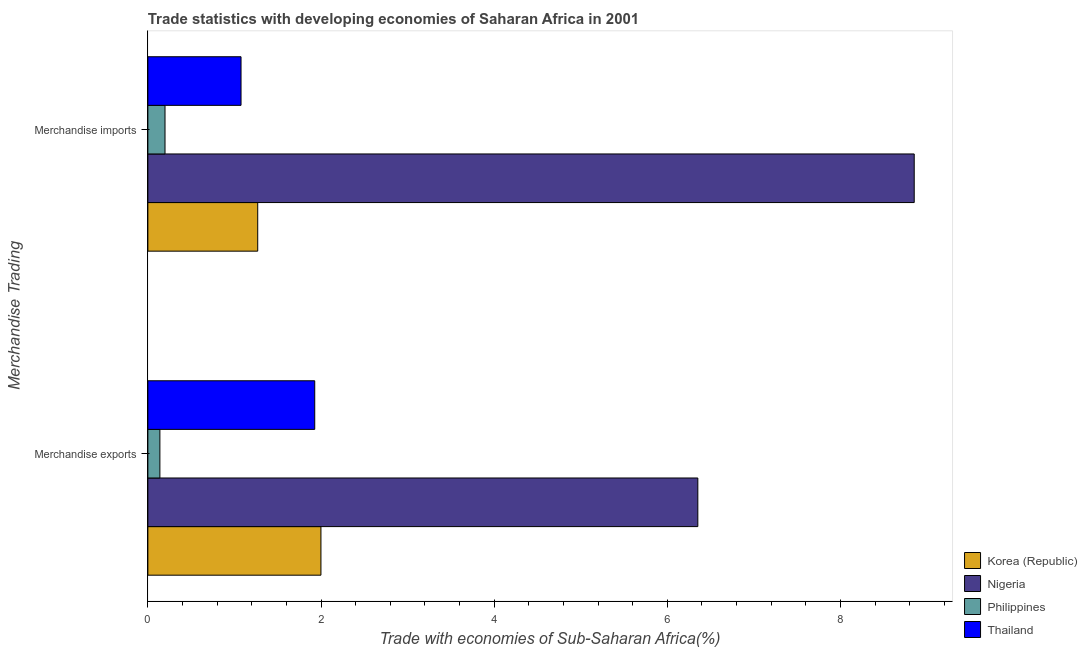Are the number of bars on each tick of the Y-axis equal?
Provide a short and direct response. Yes. What is the merchandise exports in Thailand?
Ensure brevity in your answer.  1.93. Across all countries, what is the maximum merchandise imports?
Keep it short and to the point. 8.85. Across all countries, what is the minimum merchandise imports?
Your answer should be very brief. 0.2. In which country was the merchandise imports maximum?
Ensure brevity in your answer.  Nigeria. In which country was the merchandise exports minimum?
Ensure brevity in your answer.  Philippines. What is the total merchandise imports in the graph?
Provide a succinct answer. 11.39. What is the difference between the merchandise exports in Philippines and that in Korea (Republic)?
Ensure brevity in your answer.  -1.86. What is the difference between the merchandise imports in Philippines and the merchandise exports in Thailand?
Offer a very short reply. -1.73. What is the average merchandise imports per country?
Provide a succinct answer. 2.85. What is the difference between the merchandise imports and merchandise exports in Philippines?
Provide a succinct answer. 0.06. What is the ratio of the merchandise exports in Nigeria to that in Korea (Republic)?
Your answer should be very brief. 3.18. What does the 3rd bar from the top in Merchandise exports represents?
Your answer should be compact. Nigeria. What does the 3rd bar from the bottom in Merchandise exports represents?
Offer a very short reply. Philippines. What is the difference between two consecutive major ticks on the X-axis?
Give a very brief answer. 2. Are the values on the major ticks of X-axis written in scientific E-notation?
Your answer should be compact. No. Does the graph contain any zero values?
Your answer should be very brief. No. Where does the legend appear in the graph?
Offer a terse response. Bottom right. What is the title of the graph?
Give a very brief answer. Trade statistics with developing economies of Saharan Africa in 2001. Does "Panama" appear as one of the legend labels in the graph?
Your answer should be compact. No. What is the label or title of the X-axis?
Give a very brief answer. Trade with economies of Sub-Saharan Africa(%). What is the label or title of the Y-axis?
Ensure brevity in your answer.  Merchandise Trading. What is the Trade with economies of Sub-Saharan Africa(%) in Korea (Republic) in Merchandise exports?
Give a very brief answer. 2. What is the Trade with economies of Sub-Saharan Africa(%) of Nigeria in Merchandise exports?
Ensure brevity in your answer.  6.35. What is the Trade with economies of Sub-Saharan Africa(%) of Philippines in Merchandise exports?
Provide a short and direct response. 0.14. What is the Trade with economies of Sub-Saharan Africa(%) in Thailand in Merchandise exports?
Provide a short and direct response. 1.93. What is the Trade with economies of Sub-Saharan Africa(%) in Korea (Republic) in Merchandise imports?
Your response must be concise. 1.27. What is the Trade with economies of Sub-Saharan Africa(%) of Nigeria in Merchandise imports?
Your answer should be very brief. 8.85. What is the Trade with economies of Sub-Saharan Africa(%) in Philippines in Merchandise imports?
Keep it short and to the point. 0.2. What is the Trade with economies of Sub-Saharan Africa(%) of Thailand in Merchandise imports?
Offer a terse response. 1.08. Across all Merchandise Trading, what is the maximum Trade with economies of Sub-Saharan Africa(%) of Korea (Republic)?
Give a very brief answer. 2. Across all Merchandise Trading, what is the maximum Trade with economies of Sub-Saharan Africa(%) of Nigeria?
Give a very brief answer. 8.85. Across all Merchandise Trading, what is the maximum Trade with economies of Sub-Saharan Africa(%) of Philippines?
Provide a short and direct response. 0.2. Across all Merchandise Trading, what is the maximum Trade with economies of Sub-Saharan Africa(%) in Thailand?
Give a very brief answer. 1.93. Across all Merchandise Trading, what is the minimum Trade with economies of Sub-Saharan Africa(%) of Korea (Republic)?
Give a very brief answer. 1.27. Across all Merchandise Trading, what is the minimum Trade with economies of Sub-Saharan Africa(%) in Nigeria?
Make the answer very short. 6.35. Across all Merchandise Trading, what is the minimum Trade with economies of Sub-Saharan Africa(%) of Philippines?
Your answer should be compact. 0.14. Across all Merchandise Trading, what is the minimum Trade with economies of Sub-Saharan Africa(%) in Thailand?
Your answer should be compact. 1.08. What is the total Trade with economies of Sub-Saharan Africa(%) in Korea (Republic) in the graph?
Provide a short and direct response. 3.27. What is the total Trade with economies of Sub-Saharan Africa(%) in Nigeria in the graph?
Make the answer very short. 15.2. What is the total Trade with economies of Sub-Saharan Africa(%) of Philippines in the graph?
Ensure brevity in your answer.  0.34. What is the total Trade with economies of Sub-Saharan Africa(%) of Thailand in the graph?
Give a very brief answer. 3. What is the difference between the Trade with economies of Sub-Saharan Africa(%) of Korea (Republic) in Merchandise exports and that in Merchandise imports?
Provide a short and direct response. 0.73. What is the difference between the Trade with economies of Sub-Saharan Africa(%) in Nigeria in Merchandise exports and that in Merchandise imports?
Keep it short and to the point. -2.5. What is the difference between the Trade with economies of Sub-Saharan Africa(%) of Philippines in Merchandise exports and that in Merchandise imports?
Ensure brevity in your answer.  -0.06. What is the difference between the Trade with economies of Sub-Saharan Africa(%) of Thailand in Merchandise exports and that in Merchandise imports?
Keep it short and to the point. 0.85. What is the difference between the Trade with economies of Sub-Saharan Africa(%) in Korea (Republic) in Merchandise exports and the Trade with economies of Sub-Saharan Africa(%) in Nigeria in Merchandise imports?
Offer a terse response. -6.85. What is the difference between the Trade with economies of Sub-Saharan Africa(%) of Korea (Republic) in Merchandise exports and the Trade with economies of Sub-Saharan Africa(%) of Philippines in Merchandise imports?
Offer a terse response. 1.8. What is the difference between the Trade with economies of Sub-Saharan Africa(%) of Nigeria in Merchandise exports and the Trade with economies of Sub-Saharan Africa(%) of Philippines in Merchandise imports?
Ensure brevity in your answer.  6.15. What is the difference between the Trade with economies of Sub-Saharan Africa(%) in Nigeria in Merchandise exports and the Trade with economies of Sub-Saharan Africa(%) in Thailand in Merchandise imports?
Offer a very short reply. 5.28. What is the difference between the Trade with economies of Sub-Saharan Africa(%) of Philippines in Merchandise exports and the Trade with economies of Sub-Saharan Africa(%) of Thailand in Merchandise imports?
Offer a terse response. -0.94. What is the average Trade with economies of Sub-Saharan Africa(%) of Korea (Republic) per Merchandise Trading?
Give a very brief answer. 1.63. What is the average Trade with economies of Sub-Saharan Africa(%) in Nigeria per Merchandise Trading?
Offer a very short reply. 7.6. What is the average Trade with economies of Sub-Saharan Africa(%) in Philippines per Merchandise Trading?
Offer a terse response. 0.17. What is the average Trade with economies of Sub-Saharan Africa(%) of Thailand per Merchandise Trading?
Your response must be concise. 1.5. What is the difference between the Trade with economies of Sub-Saharan Africa(%) of Korea (Republic) and Trade with economies of Sub-Saharan Africa(%) of Nigeria in Merchandise exports?
Your answer should be very brief. -4.35. What is the difference between the Trade with economies of Sub-Saharan Africa(%) of Korea (Republic) and Trade with economies of Sub-Saharan Africa(%) of Philippines in Merchandise exports?
Give a very brief answer. 1.86. What is the difference between the Trade with economies of Sub-Saharan Africa(%) of Korea (Republic) and Trade with economies of Sub-Saharan Africa(%) of Thailand in Merchandise exports?
Make the answer very short. 0.07. What is the difference between the Trade with economies of Sub-Saharan Africa(%) of Nigeria and Trade with economies of Sub-Saharan Africa(%) of Philippines in Merchandise exports?
Provide a short and direct response. 6.21. What is the difference between the Trade with economies of Sub-Saharan Africa(%) of Nigeria and Trade with economies of Sub-Saharan Africa(%) of Thailand in Merchandise exports?
Your answer should be compact. 4.42. What is the difference between the Trade with economies of Sub-Saharan Africa(%) in Philippines and Trade with economies of Sub-Saharan Africa(%) in Thailand in Merchandise exports?
Offer a terse response. -1.79. What is the difference between the Trade with economies of Sub-Saharan Africa(%) in Korea (Republic) and Trade with economies of Sub-Saharan Africa(%) in Nigeria in Merchandise imports?
Your response must be concise. -7.58. What is the difference between the Trade with economies of Sub-Saharan Africa(%) in Korea (Republic) and Trade with economies of Sub-Saharan Africa(%) in Philippines in Merchandise imports?
Make the answer very short. 1.07. What is the difference between the Trade with economies of Sub-Saharan Africa(%) of Korea (Republic) and Trade with economies of Sub-Saharan Africa(%) of Thailand in Merchandise imports?
Your answer should be compact. 0.19. What is the difference between the Trade with economies of Sub-Saharan Africa(%) of Nigeria and Trade with economies of Sub-Saharan Africa(%) of Philippines in Merchandise imports?
Ensure brevity in your answer.  8.65. What is the difference between the Trade with economies of Sub-Saharan Africa(%) in Nigeria and Trade with economies of Sub-Saharan Africa(%) in Thailand in Merchandise imports?
Keep it short and to the point. 7.78. What is the difference between the Trade with economies of Sub-Saharan Africa(%) of Philippines and Trade with economies of Sub-Saharan Africa(%) of Thailand in Merchandise imports?
Make the answer very short. -0.88. What is the ratio of the Trade with economies of Sub-Saharan Africa(%) of Korea (Republic) in Merchandise exports to that in Merchandise imports?
Offer a terse response. 1.58. What is the ratio of the Trade with economies of Sub-Saharan Africa(%) in Nigeria in Merchandise exports to that in Merchandise imports?
Provide a short and direct response. 0.72. What is the ratio of the Trade with economies of Sub-Saharan Africa(%) of Philippines in Merchandise exports to that in Merchandise imports?
Make the answer very short. 0.7. What is the ratio of the Trade with economies of Sub-Saharan Africa(%) in Thailand in Merchandise exports to that in Merchandise imports?
Your answer should be compact. 1.79. What is the difference between the highest and the second highest Trade with economies of Sub-Saharan Africa(%) in Korea (Republic)?
Give a very brief answer. 0.73. What is the difference between the highest and the second highest Trade with economies of Sub-Saharan Africa(%) in Nigeria?
Make the answer very short. 2.5. What is the difference between the highest and the second highest Trade with economies of Sub-Saharan Africa(%) in Philippines?
Ensure brevity in your answer.  0.06. What is the difference between the highest and the second highest Trade with economies of Sub-Saharan Africa(%) of Thailand?
Provide a short and direct response. 0.85. What is the difference between the highest and the lowest Trade with economies of Sub-Saharan Africa(%) of Korea (Republic)?
Offer a very short reply. 0.73. What is the difference between the highest and the lowest Trade with economies of Sub-Saharan Africa(%) of Nigeria?
Provide a succinct answer. 2.5. What is the difference between the highest and the lowest Trade with economies of Sub-Saharan Africa(%) in Philippines?
Offer a terse response. 0.06. What is the difference between the highest and the lowest Trade with economies of Sub-Saharan Africa(%) in Thailand?
Offer a terse response. 0.85. 